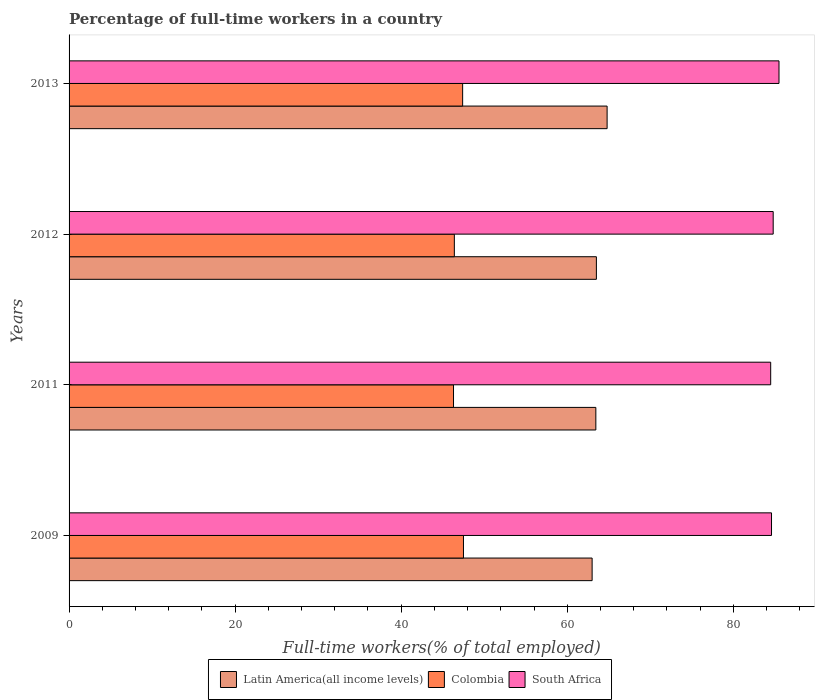Are the number of bars per tick equal to the number of legend labels?
Your answer should be compact. Yes. Are the number of bars on each tick of the Y-axis equal?
Offer a very short reply. Yes. What is the label of the 1st group of bars from the top?
Keep it short and to the point. 2013. In how many cases, is the number of bars for a given year not equal to the number of legend labels?
Provide a short and direct response. 0. What is the percentage of full-time workers in Latin America(all income levels) in 2012?
Keep it short and to the point. 63.51. Across all years, what is the maximum percentage of full-time workers in South Africa?
Provide a short and direct response. 85.5. Across all years, what is the minimum percentage of full-time workers in South Africa?
Ensure brevity in your answer.  84.5. In which year was the percentage of full-time workers in South Africa maximum?
Provide a succinct answer. 2013. What is the total percentage of full-time workers in South Africa in the graph?
Your answer should be compact. 339.4. What is the difference between the percentage of full-time workers in Latin America(all income levels) in 2009 and that in 2011?
Offer a terse response. -0.45. What is the difference between the percentage of full-time workers in South Africa in 2009 and the percentage of full-time workers in Colombia in 2011?
Your answer should be very brief. 38.3. What is the average percentage of full-time workers in South Africa per year?
Give a very brief answer. 84.85. In the year 2011, what is the difference between the percentage of full-time workers in Latin America(all income levels) and percentage of full-time workers in South Africa?
Offer a terse response. -21.06. In how many years, is the percentage of full-time workers in South Africa greater than 4 %?
Give a very brief answer. 4. What is the ratio of the percentage of full-time workers in Colombia in 2009 to that in 2013?
Ensure brevity in your answer.  1. Is the percentage of full-time workers in South Africa in 2011 less than that in 2012?
Provide a short and direct response. Yes. What is the difference between the highest and the second highest percentage of full-time workers in Colombia?
Ensure brevity in your answer.  0.1. What is the difference between the highest and the lowest percentage of full-time workers in South Africa?
Give a very brief answer. 1. Is the sum of the percentage of full-time workers in Latin America(all income levels) in 2009 and 2013 greater than the maximum percentage of full-time workers in Colombia across all years?
Offer a terse response. Yes. What does the 2nd bar from the top in 2011 represents?
Your answer should be very brief. Colombia. What does the 1st bar from the bottom in 2013 represents?
Keep it short and to the point. Latin America(all income levels). Is it the case that in every year, the sum of the percentage of full-time workers in South Africa and percentage of full-time workers in Colombia is greater than the percentage of full-time workers in Latin America(all income levels)?
Provide a succinct answer. Yes. How many bars are there?
Your answer should be very brief. 12. How many years are there in the graph?
Keep it short and to the point. 4. What is the difference between two consecutive major ticks on the X-axis?
Provide a succinct answer. 20. Are the values on the major ticks of X-axis written in scientific E-notation?
Ensure brevity in your answer.  No. Does the graph contain any zero values?
Ensure brevity in your answer.  No. Does the graph contain grids?
Offer a terse response. No. How many legend labels are there?
Offer a very short reply. 3. How are the legend labels stacked?
Your response must be concise. Horizontal. What is the title of the graph?
Make the answer very short. Percentage of full-time workers in a country. What is the label or title of the X-axis?
Offer a terse response. Full-time workers(% of total employed). What is the Full-time workers(% of total employed) in Latin America(all income levels) in 2009?
Ensure brevity in your answer.  62.99. What is the Full-time workers(% of total employed) in Colombia in 2009?
Your answer should be compact. 47.5. What is the Full-time workers(% of total employed) of South Africa in 2009?
Offer a very short reply. 84.6. What is the Full-time workers(% of total employed) in Latin America(all income levels) in 2011?
Your response must be concise. 63.44. What is the Full-time workers(% of total employed) in Colombia in 2011?
Your answer should be very brief. 46.3. What is the Full-time workers(% of total employed) of South Africa in 2011?
Offer a terse response. 84.5. What is the Full-time workers(% of total employed) in Latin America(all income levels) in 2012?
Your answer should be very brief. 63.51. What is the Full-time workers(% of total employed) of Colombia in 2012?
Ensure brevity in your answer.  46.4. What is the Full-time workers(% of total employed) in South Africa in 2012?
Offer a terse response. 84.8. What is the Full-time workers(% of total employed) in Latin America(all income levels) in 2013?
Offer a terse response. 64.8. What is the Full-time workers(% of total employed) in Colombia in 2013?
Provide a succinct answer. 47.4. What is the Full-time workers(% of total employed) of South Africa in 2013?
Your answer should be compact. 85.5. Across all years, what is the maximum Full-time workers(% of total employed) in Latin America(all income levels)?
Your response must be concise. 64.8. Across all years, what is the maximum Full-time workers(% of total employed) in Colombia?
Keep it short and to the point. 47.5. Across all years, what is the maximum Full-time workers(% of total employed) in South Africa?
Ensure brevity in your answer.  85.5. Across all years, what is the minimum Full-time workers(% of total employed) in Latin America(all income levels)?
Your response must be concise. 62.99. Across all years, what is the minimum Full-time workers(% of total employed) in Colombia?
Make the answer very short. 46.3. Across all years, what is the minimum Full-time workers(% of total employed) of South Africa?
Provide a short and direct response. 84.5. What is the total Full-time workers(% of total employed) of Latin America(all income levels) in the graph?
Ensure brevity in your answer.  254.74. What is the total Full-time workers(% of total employed) of Colombia in the graph?
Offer a very short reply. 187.6. What is the total Full-time workers(% of total employed) of South Africa in the graph?
Provide a short and direct response. 339.4. What is the difference between the Full-time workers(% of total employed) in Latin America(all income levels) in 2009 and that in 2011?
Your response must be concise. -0.45. What is the difference between the Full-time workers(% of total employed) of Colombia in 2009 and that in 2011?
Offer a terse response. 1.2. What is the difference between the Full-time workers(% of total employed) in South Africa in 2009 and that in 2011?
Offer a very short reply. 0.1. What is the difference between the Full-time workers(% of total employed) of Latin America(all income levels) in 2009 and that in 2012?
Your answer should be compact. -0.52. What is the difference between the Full-time workers(% of total employed) of Colombia in 2009 and that in 2012?
Give a very brief answer. 1.1. What is the difference between the Full-time workers(% of total employed) of Latin America(all income levels) in 2009 and that in 2013?
Keep it short and to the point. -1.81. What is the difference between the Full-time workers(% of total employed) of Latin America(all income levels) in 2011 and that in 2012?
Provide a succinct answer. -0.07. What is the difference between the Full-time workers(% of total employed) in Colombia in 2011 and that in 2012?
Make the answer very short. -0.1. What is the difference between the Full-time workers(% of total employed) of Latin America(all income levels) in 2011 and that in 2013?
Your response must be concise. -1.36. What is the difference between the Full-time workers(% of total employed) of Colombia in 2011 and that in 2013?
Offer a very short reply. -1.1. What is the difference between the Full-time workers(% of total employed) of Latin America(all income levels) in 2012 and that in 2013?
Your response must be concise. -1.29. What is the difference between the Full-time workers(% of total employed) in South Africa in 2012 and that in 2013?
Give a very brief answer. -0.7. What is the difference between the Full-time workers(% of total employed) of Latin America(all income levels) in 2009 and the Full-time workers(% of total employed) of Colombia in 2011?
Offer a very short reply. 16.69. What is the difference between the Full-time workers(% of total employed) in Latin America(all income levels) in 2009 and the Full-time workers(% of total employed) in South Africa in 2011?
Make the answer very short. -21.51. What is the difference between the Full-time workers(% of total employed) of Colombia in 2009 and the Full-time workers(% of total employed) of South Africa in 2011?
Your answer should be compact. -37. What is the difference between the Full-time workers(% of total employed) in Latin America(all income levels) in 2009 and the Full-time workers(% of total employed) in Colombia in 2012?
Your response must be concise. 16.59. What is the difference between the Full-time workers(% of total employed) in Latin America(all income levels) in 2009 and the Full-time workers(% of total employed) in South Africa in 2012?
Provide a short and direct response. -21.81. What is the difference between the Full-time workers(% of total employed) of Colombia in 2009 and the Full-time workers(% of total employed) of South Africa in 2012?
Keep it short and to the point. -37.3. What is the difference between the Full-time workers(% of total employed) in Latin America(all income levels) in 2009 and the Full-time workers(% of total employed) in Colombia in 2013?
Ensure brevity in your answer.  15.59. What is the difference between the Full-time workers(% of total employed) in Latin America(all income levels) in 2009 and the Full-time workers(% of total employed) in South Africa in 2013?
Give a very brief answer. -22.51. What is the difference between the Full-time workers(% of total employed) in Colombia in 2009 and the Full-time workers(% of total employed) in South Africa in 2013?
Offer a very short reply. -38. What is the difference between the Full-time workers(% of total employed) of Latin America(all income levels) in 2011 and the Full-time workers(% of total employed) of Colombia in 2012?
Provide a succinct answer. 17.04. What is the difference between the Full-time workers(% of total employed) of Latin America(all income levels) in 2011 and the Full-time workers(% of total employed) of South Africa in 2012?
Offer a very short reply. -21.36. What is the difference between the Full-time workers(% of total employed) in Colombia in 2011 and the Full-time workers(% of total employed) in South Africa in 2012?
Offer a very short reply. -38.5. What is the difference between the Full-time workers(% of total employed) of Latin America(all income levels) in 2011 and the Full-time workers(% of total employed) of Colombia in 2013?
Provide a short and direct response. 16.04. What is the difference between the Full-time workers(% of total employed) in Latin America(all income levels) in 2011 and the Full-time workers(% of total employed) in South Africa in 2013?
Your response must be concise. -22.06. What is the difference between the Full-time workers(% of total employed) of Colombia in 2011 and the Full-time workers(% of total employed) of South Africa in 2013?
Your answer should be very brief. -39.2. What is the difference between the Full-time workers(% of total employed) of Latin America(all income levels) in 2012 and the Full-time workers(% of total employed) of Colombia in 2013?
Provide a succinct answer. 16.11. What is the difference between the Full-time workers(% of total employed) of Latin America(all income levels) in 2012 and the Full-time workers(% of total employed) of South Africa in 2013?
Provide a short and direct response. -21.99. What is the difference between the Full-time workers(% of total employed) of Colombia in 2012 and the Full-time workers(% of total employed) of South Africa in 2013?
Offer a terse response. -39.1. What is the average Full-time workers(% of total employed) of Latin America(all income levels) per year?
Provide a succinct answer. 63.69. What is the average Full-time workers(% of total employed) in Colombia per year?
Give a very brief answer. 46.9. What is the average Full-time workers(% of total employed) of South Africa per year?
Keep it short and to the point. 84.85. In the year 2009, what is the difference between the Full-time workers(% of total employed) in Latin America(all income levels) and Full-time workers(% of total employed) in Colombia?
Your response must be concise. 15.49. In the year 2009, what is the difference between the Full-time workers(% of total employed) of Latin America(all income levels) and Full-time workers(% of total employed) of South Africa?
Your response must be concise. -21.61. In the year 2009, what is the difference between the Full-time workers(% of total employed) of Colombia and Full-time workers(% of total employed) of South Africa?
Make the answer very short. -37.1. In the year 2011, what is the difference between the Full-time workers(% of total employed) of Latin America(all income levels) and Full-time workers(% of total employed) of Colombia?
Offer a very short reply. 17.14. In the year 2011, what is the difference between the Full-time workers(% of total employed) of Latin America(all income levels) and Full-time workers(% of total employed) of South Africa?
Offer a terse response. -21.06. In the year 2011, what is the difference between the Full-time workers(% of total employed) in Colombia and Full-time workers(% of total employed) in South Africa?
Ensure brevity in your answer.  -38.2. In the year 2012, what is the difference between the Full-time workers(% of total employed) of Latin America(all income levels) and Full-time workers(% of total employed) of Colombia?
Your answer should be compact. 17.11. In the year 2012, what is the difference between the Full-time workers(% of total employed) of Latin America(all income levels) and Full-time workers(% of total employed) of South Africa?
Make the answer very short. -21.29. In the year 2012, what is the difference between the Full-time workers(% of total employed) in Colombia and Full-time workers(% of total employed) in South Africa?
Provide a short and direct response. -38.4. In the year 2013, what is the difference between the Full-time workers(% of total employed) of Latin America(all income levels) and Full-time workers(% of total employed) of Colombia?
Offer a terse response. 17.4. In the year 2013, what is the difference between the Full-time workers(% of total employed) in Latin America(all income levels) and Full-time workers(% of total employed) in South Africa?
Offer a terse response. -20.7. In the year 2013, what is the difference between the Full-time workers(% of total employed) of Colombia and Full-time workers(% of total employed) of South Africa?
Keep it short and to the point. -38.1. What is the ratio of the Full-time workers(% of total employed) of Latin America(all income levels) in 2009 to that in 2011?
Your answer should be very brief. 0.99. What is the ratio of the Full-time workers(% of total employed) of Colombia in 2009 to that in 2011?
Give a very brief answer. 1.03. What is the ratio of the Full-time workers(% of total employed) of South Africa in 2009 to that in 2011?
Provide a succinct answer. 1. What is the ratio of the Full-time workers(% of total employed) of Colombia in 2009 to that in 2012?
Provide a succinct answer. 1.02. What is the ratio of the Full-time workers(% of total employed) in Latin America(all income levels) in 2009 to that in 2013?
Ensure brevity in your answer.  0.97. What is the ratio of the Full-time workers(% of total employed) of Colombia in 2011 to that in 2012?
Your answer should be very brief. 1. What is the ratio of the Full-time workers(% of total employed) of South Africa in 2011 to that in 2012?
Make the answer very short. 1. What is the ratio of the Full-time workers(% of total employed) in Colombia in 2011 to that in 2013?
Give a very brief answer. 0.98. What is the ratio of the Full-time workers(% of total employed) of South Africa in 2011 to that in 2013?
Keep it short and to the point. 0.99. What is the ratio of the Full-time workers(% of total employed) in Latin America(all income levels) in 2012 to that in 2013?
Give a very brief answer. 0.98. What is the ratio of the Full-time workers(% of total employed) of Colombia in 2012 to that in 2013?
Offer a terse response. 0.98. What is the difference between the highest and the second highest Full-time workers(% of total employed) of Latin America(all income levels)?
Your answer should be very brief. 1.29. What is the difference between the highest and the second highest Full-time workers(% of total employed) in Colombia?
Offer a very short reply. 0.1. What is the difference between the highest and the second highest Full-time workers(% of total employed) in South Africa?
Ensure brevity in your answer.  0.7. What is the difference between the highest and the lowest Full-time workers(% of total employed) in Latin America(all income levels)?
Provide a short and direct response. 1.81. What is the difference between the highest and the lowest Full-time workers(% of total employed) of South Africa?
Offer a terse response. 1. 